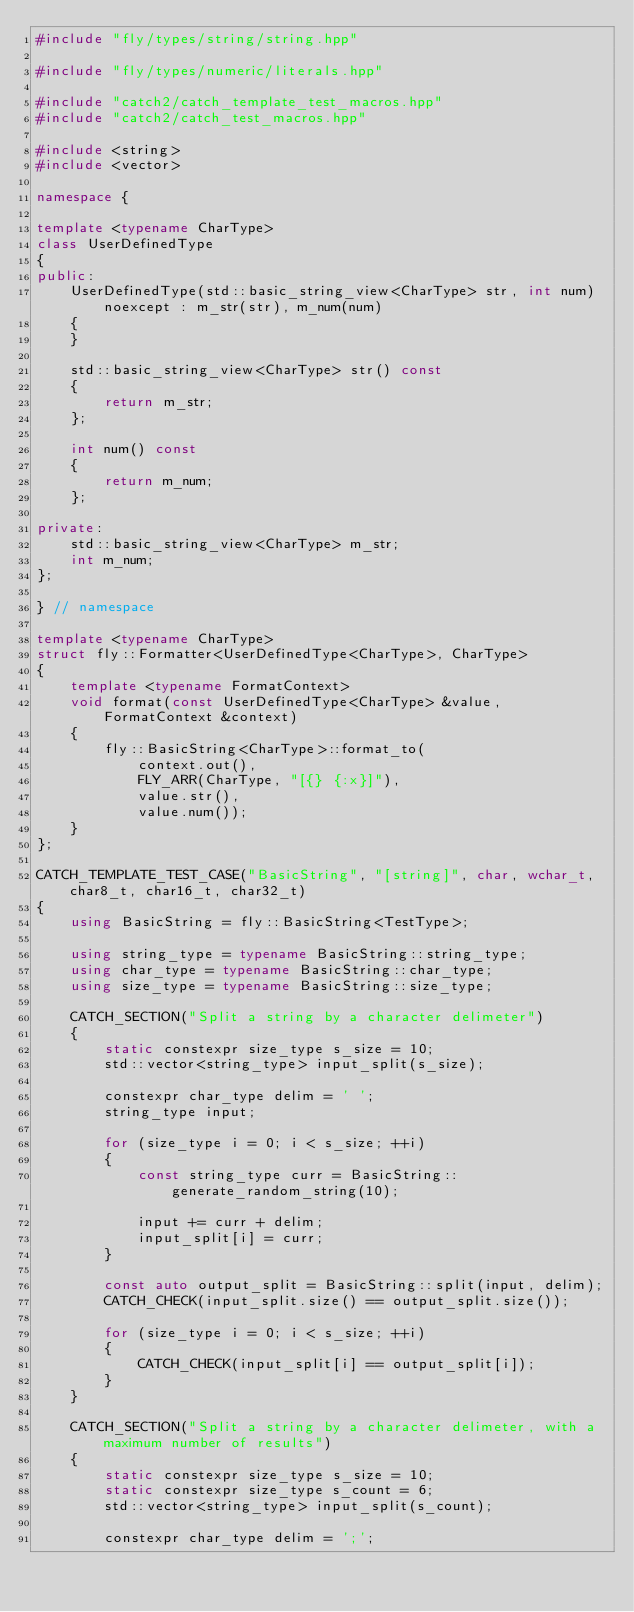Convert code to text. <code><loc_0><loc_0><loc_500><loc_500><_C++_>#include "fly/types/string/string.hpp"

#include "fly/types/numeric/literals.hpp"

#include "catch2/catch_template_test_macros.hpp"
#include "catch2/catch_test_macros.hpp"

#include <string>
#include <vector>

namespace {

template <typename CharType>
class UserDefinedType
{
public:
    UserDefinedType(std::basic_string_view<CharType> str, int num) noexcept : m_str(str), m_num(num)
    {
    }

    std::basic_string_view<CharType> str() const
    {
        return m_str;
    };

    int num() const
    {
        return m_num;
    };

private:
    std::basic_string_view<CharType> m_str;
    int m_num;
};

} // namespace

template <typename CharType>
struct fly::Formatter<UserDefinedType<CharType>, CharType>
{
    template <typename FormatContext>
    void format(const UserDefinedType<CharType> &value, FormatContext &context)
    {
        fly::BasicString<CharType>::format_to(
            context.out(),
            FLY_ARR(CharType, "[{} {:x}]"),
            value.str(),
            value.num());
    }
};

CATCH_TEMPLATE_TEST_CASE("BasicString", "[string]", char, wchar_t, char8_t, char16_t, char32_t)
{
    using BasicString = fly::BasicString<TestType>;

    using string_type = typename BasicString::string_type;
    using char_type = typename BasicString::char_type;
    using size_type = typename BasicString::size_type;

    CATCH_SECTION("Split a string by a character delimeter")
    {
        static constexpr size_type s_size = 10;
        std::vector<string_type> input_split(s_size);

        constexpr char_type delim = ' ';
        string_type input;

        for (size_type i = 0; i < s_size; ++i)
        {
            const string_type curr = BasicString::generate_random_string(10);

            input += curr + delim;
            input_split[i] = curr;
        }

        const auto output_split = BasicString::split(input, delim);
        CATCH_CHECK(input_split.size() == output_split.size());

        for (size_type i = 0; i < s_size; ++i)
        {
            CATCH_CHECK(input_split[i] == output_split[i]);
        }
    }

    CATCH_SECTION("Split a string by a character delimeter, with a maximum number of results")
    {
        static constexpr size_type s_size = 10;
        static constexpr size_type s_count = 6;
        std::vector<string_type> input_split(s_count);

        constexpr char_type delim = ';';</code> 